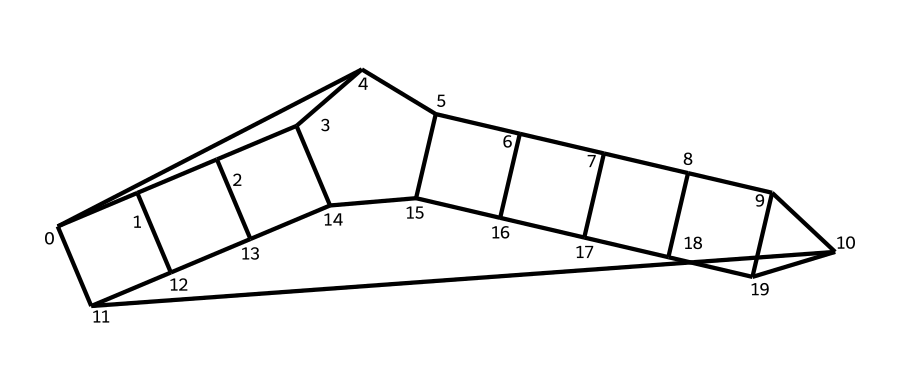How many carbon atoms are present in dodecahedrane? The SMILES notation indicates a structure with 12 carbon atoms, as each "C" represents a carbon in the molecular structure.
Answer: twelve What type of structure does dodecahedrane have? Dodecahedrane's SMILES representation suggests a highly symmetrical cage structure typical of polyhedral compounds.
Answer: cage What is the molecular formula of dodecahedrane? Given the presence of twelve carbon atoms and the typical hydrogen count for such a structure (around 24), the molecular formula can be deduced as C12H24.
Answer: C12H24 Which feature of dodecahedrane contributes to its symmetry? The interconnected and uniform arrangement of its carbon atoms in a polyhedral configuration creates a highly symmetrical form.
Answer: uniform arrangement What symmetry order does dodecahedrane exhibit? Based on its structure, dodecahedrane exhibits icosahedral symmetry, which is characteristic of certain cage compounds.
Answer: icosahedral How many hydrogen atoms are typically bonded to each carbon in dodecahedrane? Each carbon in dodecahedrane typically bonds with two hydrogen atoms, due to the saturated nature of the compound and the total count of hydrogens being 24.
Answer: two What is the significance of the cage structure in terms of molecular stability? The cage structure enhances molecular stability by creating a closed 3D arrangement that minimizes strain and maximizes symmetry.
Answer: stability 